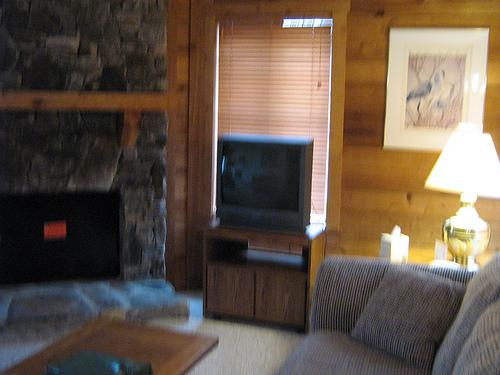Question: where is this picture taken?
Choices:
A. A living room.
B. A kitchen.
C. A dining room.
D. A bedroom.
Answer with the letter. Answer: A Question: why is there a fireplace?
Choices:
A. For roasting marshmallows.
B. For cold nights.
C. For decoration.
D. For popping popcorn.
Answer with the letter. Answer: B Question: when was this picture taken?
Choices:
A. In the morning.
B. In the afternoon.
C. At daytime.
D. At sunset.
Answer with the letter. Answer: C Question: what is the material on the walls?
Choices:
A. Wood.
B. Glass.
C. Metal.
D. Fabric.
Answer with the letter. Answer: A 